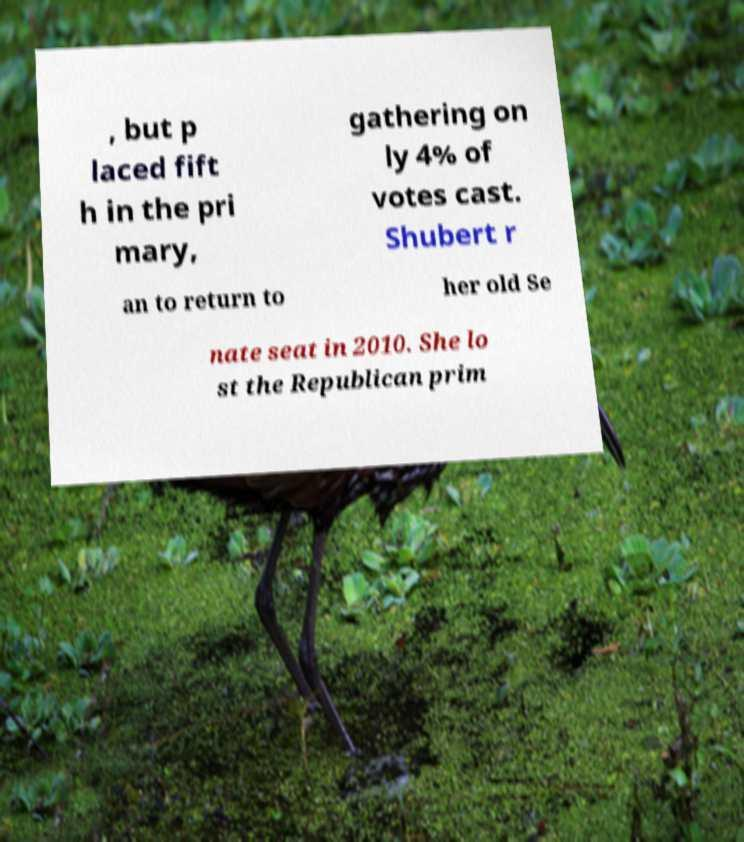For documentation purposes, I need the text within this image transcribed. Could you provide that? , but p laced fift h in the pri mary, gathering on ly 4% of votes cast. Shubert r an to return to her old Se nate seat in 2010. She lo st the Republican prim 